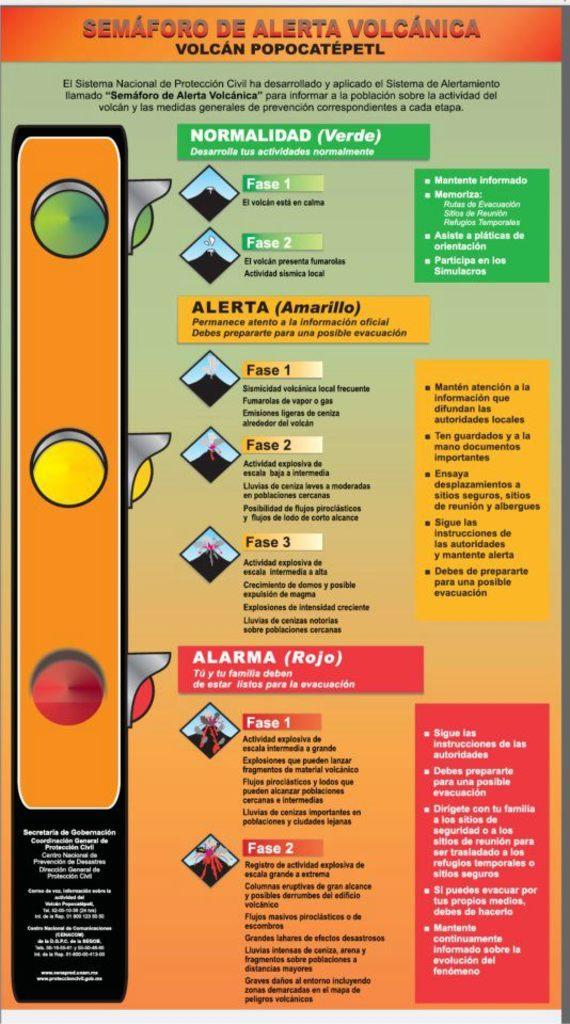Provide a one-sentence caption for the provided image. Instructions for a homemade volcano are displayed on this flyer. 